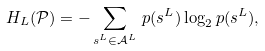<formula> <loc_0><loc_0><loc_500><loc_500>H _ { L } ( \mathcal { P } ) = - \sum _ { s ^ { L } \in \mathcal { A } ^ { L } } \, p ( s ^ { L } ) \log _ { 2 } p ( s ^ { L } ) ,</formula> 